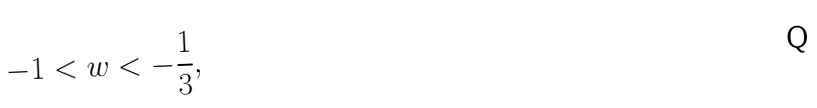Convert formula to latex. <formula><loc_0><loc_0><loc_500><loc_500>- 1 < w < - \frac { 1 } { 3 } ,</formula> 